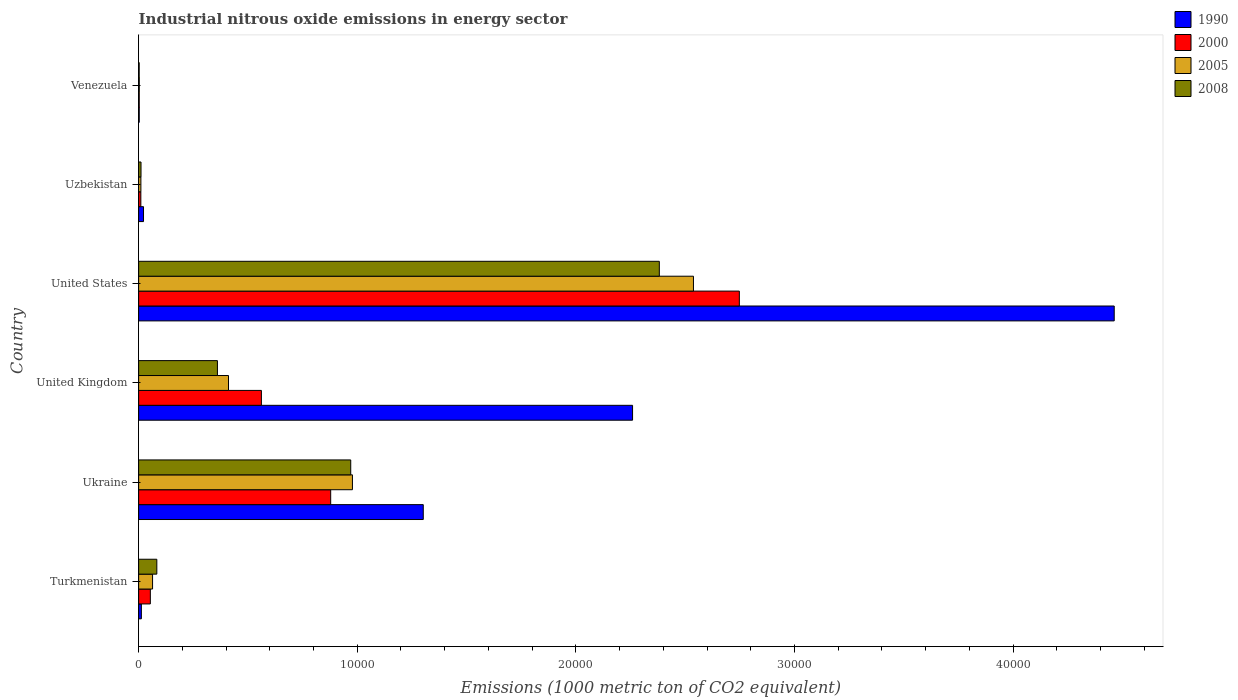How many different coloured bars are there?
Provide a short and direct response. 4. Are the number of bars per tick equal to the number of legend labels?
Keep it short and to the point. Yes. How many bars are there on the 6th tick from the top?
Make the answer very short. 4. How many bars are there on the 1st tick from the bottom?
Give a very brief answer. 4. What is the amount of industrial nitrous oxide emitted in 1990 in United States?
Make the answer very short. 4.46e+04. Across all countries, what is the maximum amount of industrial nitrous oxide emitted in 2008?
Make the answer very short. 2.38e+04. Across all countries, what is the minimum amount of industrial nitrous oxide emitted in 2000?
Your answer should be very brief. 27.9. In which country was the amount of industrial nitrous oxide emitted in 1990 minimum?
Offer a very short reply. Venezuela. What is the total amount of industrial nitrous oxide emitted in 2008 in the graph?
Offer a very short reply. 3.81e+04. What is the difference between the amount of industrial nitrous oxide emitted in 2005 in Ukraine and that in Uzbekistan?
Give a very brief answer. 9676.7. What is the difference between the amount of industrial nitrous oxide emitted in 2008 in Venezuela and the amount of industrial nitrous oxide emitted in 1990 in United Kingdom?
Ensure brevity in your answer.  -2.26e+04. What is the average amount of industrial nitrous oxide emitted in 2005 per country?
Give a very brief answer. 6673.38. What is the difference between the amount of industrial nitrous oxide emitted in 1990 and amount of industrial nitrous oxide emitted in 2000 in Ukraine?
Keep it short and to the point. 4235.2. What is the ratio of the amount of industrial nitrous oxide emitted in 2000 in United States to that in Uzbekistan?
Offer a very short reply. 270.45. Is the amount of industrial nitrous oxide emitted in 1990 in Ukraine less than that in United Kingdom?
Keep it short and to the point. Yes. Is the difference between the amount of industrial nitrous oxide emitted in 1990 in Uzbekistan and Venezuela greater than the difference between the amount of industrial nitrous oxide emitted in 2000 in Uzbekistan and Venezuela?
Offer a terse response. Yes. What is the difference between the highest and the second highest amount of industrial nitrous oxide emitted in 2005?
Give a very brief answer. 1.56e+04. What is the difference between the highest and the lowest amount of industrial nitrous oxide emitted in 1990?
Give a very brief answer. 4.46e+04. Is the sum of the amount of industrial nitrous oxide emitted in 2000 in Ukraine and Uzbekistan greater than the maximum amount of industrial nitrous oxide emitted in 1990 across all countries?
Your answer should be very brief. No. Is it the case that in every country, the sum of the amount of industrial nitrous oxide emitted in 2000 and amount of industrial nitrous oxide emitted in 2008 is greater than the sum of amount of industrial nitrous oxide emitted in 1990 and amount of industrial nitrous oxide emitted in 2005?
Offer a terse response. No. What does the 2nd bar from the bottom in United Kingdom represents?
Your response must be concise. 2000. Is it the case that in every country, the sum of the amount of industrial nitrous oxide emitted in 1990 and amount of industrial nitrous oxide emitted in 2008 is greater than the amount of industrial nitrous oxide emitted in 2005?
Offer a terse response. Yes. How many countries are there in the graph?
Offer a terse response. 6. Does the graph contain grids?
Make the answer very short. No. Where does the legend appear in the graph?
Make the answer very short. Top right. How many legend labels are there?
Keep it short and to the point. 4. How are the legend labels stacked?
Your response must be concise. Vertical. What is the title of the graph?
Keep it short and to the point. Industrial nitrous oxide emissions in energy sector. Does "1997" appear as one of the legend labels in the graph?
Keep it short and to the point. No. What is the label or title of the X-axis?
Keep it short and to the point. Emissions (1000 metric ton of CO2 equivalent). What is the Emissions (1000 metric ton of CO2 equivalent) of 1990 in Turkmenistan?
Provide a succinct answer. 125.6. What is the Emissions (1000 metric ton of CO2 equivalent) of 2000 in Turkmenistan?
Give a very brief answer. 535.7. What is the Emissions (1000 metric ton of CO2 equivalent) of 2005 in Turkmenistan?
Ensure brevity in your answer.  637.2. What is the Emissions (1000 metric ton of CO2 equivalent) of 2008 in Turkmenistan?
Give a very brief answer. 832.5. What is the Emissions (1000 metric ton of CO2 equivalent) of 1990 in Ukraine?
Offer a terse response. 1.30e+04. What is the Emissions (1000 metric ton of CO2 equivalent) of 2000 in Ukraine?
Offer a terse response. 8784.8. What is the Emissions (1000 metric ton of CO2 equivalent) of 2005 in Ukraine?
Provide a succinct answer. 9779.9. What is the Emissions (1000 metric ton of CO2 equivalent) in 2008 in Ukraine?
Make the answer very short. 9701.8. What is the Emissions (1000 metric ton of CO2 equivalent) in 1990 in United Kingdom?
Keep it short and to the point. 2.26e+04. What is the Emissions (1000 metric ton of CO2 equivalent) of 2000 in United Kingdom?
Keep it short and to the point. 5616. What is the Emissions (1000 metric ton of CO2 equivalent) in 2005 in United Kingdom?
Make the answer very short. 4111.2. What is the Emissions (1000 metric ton of CO2 equivalent) of 2008 in United Kingdom?
Offer a very short reply. 3604.6. What is the Emissions (1000 metric ton of CO2 equivalent) in 1990 in United States?
Your answer should be compact. 4.46e+04. What is the Emissions (1000 metric ton of CO2 equivalent) in 2000 in United States?
Provide a succinct answer. 2.75e+04. What is the Emissions (1000 metric ton of CO2 equivalent) of 2005 in United States?
Your answer should be compact. 2.54e+04. What is the Emissions (1000 metric ton of CO2 equivalent) of 2008 in United States?
Make the answer very short. 2.38e+04. What is the Emissions (1000 metric ton of CO2 equivalent) of 1990 in Uzbekistan?
Make the answer very short. 223.2. What is the Emissions (1000 metric ton of CO2 equivalent) of 2000 in Uzbekistan?
Give a very brief answer. 101.6. What is the Emissions (1000 metric ton of CO2 equivalent) in 2005 in Uzbekistan?
Keep it short and to the point. 103.2. What is the Emissions (1000 metric ton of CO2 equivalent) in 2008 in Uzbekistan?
Your response must be concise. 109.4. What is the Emissions (1000 metric ton of CO2 equivalent) of 1990 in Venezuela?
Ensure brevity in your answer.  27.9. What is the Emissions (1000 metric ton of CO2 equivalent) in 2000 in Venezuela?
Your answer should be compact. 27.9. What is the Emissions (1000 metric ton of CO2 equivalent) in 2005 in Venezuela?
Offer a terse response. 30.1. What is the Emissions (1000 metric ton of CO2 equivalent) in 2008 in Venezuela?
Offer a terse response. 25.4. Across all countries, what is the maximum Emissions (1000 metric ton of CO2 equivalent) in 1990?
Ensure brevity in your answer.  4.46e+04. Across all countries, what is the maximum Emissions (1000 metric ton of CO2 equivalent) in 2000?
Offer a very short reply. 2.75e+04. Across all countries, what is the maximum Emissions (1000 metric ton of CO2 equivalent) in 2005?
Your answer should be compact. 2.54e+04. Across all countries, what is the maximum Emissions (1000 metric ton of CO2 equivalent) in 2008?
Your answer should be compact. 2.38e+04. Across all countries, what is the minimum Emissions (1000 metric ton of CO2 equivalent) in 1990?
Your response must be concise. 27.9. Across all countries, what is the minimum Emissions (1000 metric ton of CO2 equivalent) of 2000?
Provide a succinct answer. 27.9. Across all countries, what is the minimum Emissions (1000 metric ton of CO2 equivalent) in 2005?
Keep it short and to the point. 30.1. Across all countries, what is the minimum Emissions (1000 metric ton of CO2 equivalent) in 2008?
Offer a very short reply. 25.4. What is the total Emissions (1000 metric ton of CO2 equivalent) of 1990 in the graph?
Offer a very short reply. 8.06e+04. What is the total Emissions (1000 metric ton of CO2 equivalent) of 2000 in the graph?
Your answer should be very brief. 4.25e+04. What is the total Emissions (1000 metric ton of CO2 equivalent) in 2005 in the graph?
Keep it short and to the point. 4.00e+04. What is the total Emissions (1000 metric ton of CO2 equivalent) of 2008 in the graph?
Make the answer very short. 3.81e+04. What is the difference between the Emissions (1000 metric ton of CO2 equivalent) of 1990 in Turkmenistan and that in Ukraine?
Keep it short and to the point. -1.29e+04. What is the difference between the Emissions (1000 metric ton of CO2 equivalent) in 2000 in Turkmenistan and that in Ukraine?
Provide a succinct answer. -8249.1. What is the difference between the Emissions (1000 metric ton of CO2 equivalent) in 2005 in Turkmenistan and that in Ukraine?
Give a very brief answer. -9142.7. What is the difference between the Emissions (1000 metric ton of CO2 equivalent) of 2008 in Turkmenistan and that in Ukraine?
Keep it short and to the point. -8869.3. What is the difference between the Emissions (1000 metric ton of CO2 equivalent) in 1990 in Turkmenistan and that in United Kingdom?
Keep it short and to the point. -2.25e+04. What is the difference between the Emissions (1000 metric ton of CO2 equivalent) in 2000 in Turkmenistan and that in United Kingdom?
Your response must be concise. -5080.3. What is the difference between the Emissions (1000 metric ton of CO2 equivalent) in 2005 in Turkmenistan and that in United Kingdom?
Your response must be concise. -3474. What is the difference between the Emissions (1000 metric ton of CO2 equivalent) of 2008 in Turkmenistan and that in United Kingdom?
Keep it short and to the point. -2772.1. What is the difference between the Emissions (1000 metric ton of CO2 equivalent) of 1990 in Turkmenistan and that in United States?
Keep it short and to the point. -4.45e+04. What is the difference between the Emissions (1000 metric ton of CO2 equivalent) of 2000 in Turkmenistan and that in United States?
Keep it short and to the point. -2.69e+04. What is the difference between the Emissions (1000 metric ton of CO2 equivalent) in 2005 in Turkmenistan and that in United States?
Your answer should be compact. -2.47e+04. What is the difference between the Emissions (1000 metric ton of CO2 equivalent) of 2008 in Turkmenistan and that in United States?
Offer a very short reply. -2.30e+04. What is the difference between the Emissions (1000 metric ton of CO2 equivalent) in 1990 in Turkmenistan and that in Uzbekistan?
Make the answer very short. -97.6. What is the difference between the Emissions (1000 metric ton of CO2 equivalent) in 2000 in Turkmenistan and that in Uzbekistan?
Provide a succinct answer. 434.1. What is the difference between the Emissions (1000 metric ton of CO2 equivalent) in 2005 in Turkmenistan and that in Uzbekistan?
Ensure brevity in your answer.  534. What is the difference between the Emissions (1000 metric ton of CO2 equivalent) of 2008 in Turkmenistan and that in Uzbekistan?
Provide a succinct answer. 723.1. What is the difference between the Emissions (1000 metric ton of CO2 equivalent) in 1990 in Turkmenistan and that in Venezuela?
Give a very brief answer. 97.7. What is the difference between the Emissions (1000 metric ton of CO2 equivalent) in 2000 in Turkmenistan and that in Venezuela?
Provide a short and direct response. 507.8. What is the difference between the Emissions (1000 metric ton of CO2 equivalent) in 2005 in Turkmenistan and that in Venezuela?
Provide a succinct answer. 607.1. What is the difference between the Emissions (1000 metric ton of CO2 equivalent) of 2008 in Turkmenistan and that in Venezuela?
Ensure brevity in your answer.  807.1. What is the difference between the Emissions (1000 metric ton of CO2 equivalent) in 1990 in Ukraine and that in United Kingdom?
Make the answer very short. -9573. What is the difference between the Emissions (1000 metric ton of CO2 equivalent) of 2000 in Ukraine and that in United Kingdom?
Make the answer very short. 3168.8. What is the difference between the Emissions (1000 metric ton of CO2 equivalent) in 2005 in Ukraine and that in United Kingdom?
Provide a short and direct response. 5668.7. What is the difference between the Emissions (1000 metric ton of CO2 equivalent) of 2008 in Ukraine and that in United Kingdom?
Provide a short and direct response. 6097.2. What is the difference between the Emissions (1000 metric ton of CO2 equivalent) of 1990 in Ukraine and that in United States?
Give a very brief answer. -3.16e+04. What is the difference between the Emissions (1000 metric ton of CO2 equivalent) of 2000 in Ukraine and that in United States?
Offer a very short reply. -1.87e+04. What is the difference between the Emissions (1000 metric ton of CO2 equivalent) of 2005 in Ukraine and that in United States?
Offer a very short reply. -1.56e+04. What is the difference between the Emissions (1000 metric ton of CO2 equivalent) in 2008 in Ukraine and that in United States?
Ensure brevity in your answer.  -1.41e+04. What is the difference between the Emissions (1000 metric ton of CO2 equivalent) in 1990 in Ukraine and that in Uzbekistan?
Offer a terse response. 1.28e+04. What is the difference between the Emissions (1000 metric ton of CO2 equivalent) in 2000 in Ukraine and that in Uzbekistan?
Make the answer very short. 8683.2. What is the difference between the Emissions (1000 metric ton of CO2 equivalent) of 2005 in Ukraine and that in Uzbekistan?
Keep it short and to the point. 9676.7. What is the difference between the Emissions (1000 metric ton of CO2 equivalent) in 2008 in Ukraine and that in Uzbekistan?
Offer a terse response. 9592.4. What is the difference between the Emissions (1000 metric ton of CO2 equivalent) in 1990 in Ukraine and that in Venezuela?
Provide a short and direct response. 1.30e+04. What is the difference between the Emissions (1000 metric ton of CO2 equivalent) of 2000 in Ukraine and that in Venezuela?
Make the answer very short. 8756.9. What is the difference between the Emissions (1000 metric ton of CO2 equivalent) in 2005 in Ukraine and that in Venezuela?
Keep it short and to the point. 9749.8. What is the difference between the Emissions (1000 metric ton of CO2 equivalent) in 2008 in Ukraine and that in Venezuela?
Your response must be concise. 9676.4. What is the difference between the Emissions (1000 metric ton of CO2 equivalent) of 1990 in United Kingdom and that in United States?
Your answer should be compact. -2.20e+04. What is the difference between the Emissions (1000 metric ton of CO2 equivalent) in 2000 in United Kingdom and that in United States?
Keep it short and to the point. -2.19e+04. What is the difference between the Emissions (1000 metric ton of CO2 equivalent) in 2005 in United Kingdom and that in United States?
Your answer should be very brief. -2.13e+04. What is the difference between the Emissions (1000 metric ton of CO2 equivalent) in 2008 in United Kingdom and that in United States?
Provide a short and direct response. -2.02e+04. What is the difference between the Emissions (1000 metric ton of CO2 equivalent) in 1990 in United Kingdom and that in Uzbekistan?
Give a very brief answer. 2.24e+04. What is the difference between the Emissions (1000 metric ton of CO2 equivalent) in 2000 in United Kingdom and that in Uzbekistan?
Offer a terse response. 5514.4. What is the difference between the Emissions (1000 metric ton of CO2 equivalent) in 2005 in United Kingdom and that in Uzbekistan?
Ensure brevity in your answer.  4008. What is the difference between the Emissions (1000 metric ton of CO2 equivalent) of 2008 in United Kingdom and that in Uzbekistan?
Ensure brevity in your answer.  3495.2. What is the difference between the Emissions (1000 metric ton of CO2 equivalent) of 1990 in United Kingdom and that in Venezuela?
Your response must be concise. 2.26e+04. What is the difference between the Emissions (1000 metric ton of CO2 equivalent) in 2000 in United Kingdom and that in Venezuela?
Ensure brevity in your answer.  5588.1. What is the difference between the Emissions (1000 metric ton of CO2 equivalent) of 2005 in United Kingdom and that in Venezuela?
Offer a very short reply. 4081.1. What is the difference between the Emissions (1000 metric ton of CO2 equivalent) of 2008 in United Kingdom and that in Venezuela?
Give a very brief answer. 3579.2. What is the difference between the Emissions (1000 metric ton of CO2 equivalent) of 1990 in United States and that in Uzbekistan?
Provide a short and direct response. 4.44e+04. What is the difference between the Emissions (1000 metric ton of CO2 equivalent) of 2000 in United States and that in Uzbekistan?
Offer a very short reply. 2.74e+04. What is the difference between the Emissions (1000 metric ton of CO2 equivalent) of 2005 in United States and that in Uzbekistan?
Your response must be concise. 2.53e+04. What is the difference between the Emissions (1000 metric ton of CO2 equivalent) of 2008 in United States and that in Uzbekistan?
Your answer should be very brief. 2.37e+04. What is the difference between the Emissions (1000 metric ton of CO2 equivalent) of 1990 in United States and that in Venezuela?
Your answer should be very brief. 4.46e+04. What is the difference between the Emissions (1000 metric ton of CO2 equivalent) in 2000 in United States and that in Venezuela?
Ensure brevity in your answer.  2.74e+04. What is the difference between the Emissions (1000 metric ton of CO2 equivalent) in 2005 in United States and that in Venezuela?
Provide a succinct answer. 2.53e+04. What is the difference between the Emissions (1000 metric ton of CO2 equivalent) of 2008 in United States and that in Venezuela?
Provide a short and direct response. 2.38e+04. What is the difference between the Emissions (1000 metric ton of CO2 equivalent) in 1990 in Uzbekistan and that in Venezuela?
Your answer should be compact. 195.3. What is the difference between the Emissions (1000 metric ton of CO2 equivalent) of 2000 in Uzbekistan and that in Venezuela?
Keep it short and to the point. 73.7. What is the difference between the Emissions (1000 metric ton of CO2 equivalent) in 2005 in Uzbekistan and that in Venezuela?
Keep it short and to the point. 73.1. What is the difference between the Emissions (1000 metric ton of CO2 equivalent) of 2008 in Uzbekistan and that in Venezuela?
Your response must be concise. 84. What is the difference between the Emissions (1000 metric ton of CO2 equivalent) of 1990 in Turkmenistan and the Emissions (1000 metric ton of CO2 equivalent) of 2000 in Ukraine?
Your answer should be compact. -8659.2. What is the difference between the Emissions (1000 metric ton of CO2 equivalent) of 1990 in Turkmenistan and the Emissions (1000 metric ton of CO2 equivalent) of 2005 in Ukraine?
Offer a very short reply. -9654.3. What is the difference between the Emissions (1000 metric ton of CO2 equivalent) of 1990 in Turkmenistan and the Emissions (1000 metric ton of CO2 equivalent) of 2008 in Ukraine?
Your answer should be very brief. -9576.2. What is the difference between the Emissions (1000 metric ton of CO2 equivalent) in 2000 in Turkmenistan and the Emissions (1000 metric ton of CO2 equivalent) in 2005 in Ukraine?
Your answer should be very brief. -9244.2. What is the difference between the Emissions (1000 metric ton of CO2 equivalent) in 2000 in Turkmenistan and the Emissions (1000 metric ton of CO2 equivalent) in 2008 in Ukraine?
Provide a succinct answer. -9166.1. What is the difference between the Emissions (1000 metric ton of CO2 equivalent) in 2005 in Turkmenistan and the Emissions (1000 metric ton of CO2 equivalent) in 2008 in Ukraine?
Your response must be concise. -9064.6. What is the difference between the Emissions (1000 metric ton of CO2 equivalent) in 1990 in Turkmenistan and the Emissions (1000 metric ton of CO2 equivalent) in 2000 in United Kingdom?
Your answer should be very brief. -5490.4. What is the difference between the Emissions (1000 metric ton of CO2 equivalent) in 1990 in Turkmenistan and the Emissions (1000 metric ton of CO2 equivalent) in 2005 in United Kingdom?
Ensure brevity in your answer.  -3985.6. What is the difference between the Emissions (1000 metric ton of CO2 equivalent) in 1990 in Turkmenistan and the Emissions (1000 metric ton of CO2 equivalent) in 2008 in United Kingdom?
Provide a short and direct response. -3479. What is the difference between the Emissions (1000 metric ton of CO2 equivalent) in 2000 in Turkmenistan and the Emissions (1000 metric ton of CO2 equivalent) in 2005 in United Kingdom?
Your answer should be compact. -3575.5. What is the difference between the Emissions (1000 metric ton of CO2 equivalent) in 2000 in Turkmenistan and the Emissions (1000 metric ton of CO2 equivalent) in 2008 in United Kingdom?
Provide a succinct answer. -3068.9. What is the difference between the Emissions (1000 metric ton of CO2 equivalent) of 2005 in Turkmenistan and the Emissions (1000 metric ton of CO2 equivalent) of 2008 in United Kingdom?
Ensure brevity in your answer.  -2967.4. What is the difference between the Emissions (1000 metric ton of CO2 equivalent) in 1990 in Turkmenistan and the Emissions (1000 metric ton of CO2 equivalent) in 2000 in United States?
Make the answer very short. -2.74e+04. What is the difference between the Emissions (1000 metric ton of CO2 equivalent) in 1990 in Turkmenistan and the Emissions (1000 metric ton of CO2 equivalent) in 2005 in United States?
Your response must be concise. -2.53e+04. What is the difference between the Emissions (1000 metric ton of CO2 equivalent) in 1990 in Turkmenistan and the Emissions (1000 metric ton of CO2 equivalent) in 2008 in United States?
Offer a very short reply. -2.37e+04. What is the difference between the Emissions (1000 metric ton of CO2 equivalent) in 2000 in Turkmenistan and the Emissions (1000 metric ton of CO2 equivalent) in 2005 in United States?
Offer a terse response. -2.48e+04. What is the difference between the Emissions (1000 metric ton of CO2 equivalent) in 2000 in Turkmenistan and the Emissions (1000 metric ton of CO2 equivalent) in 2008 in United States?
Your answer should be very brief. -2.33e+04. What is the difference between the Emissions (1000 metric ton of CO2 equivalent) in 2005 in Turkmenistan and the Emissions (1000 metric ton of CO2 equivalent) in 2008 in United States?
Make the answer very short. -2.32e+04. What is the difference between the Emissions (1000 metric ton of CO2 equivalent) in 1990 in Turkmenistan and the Emissions (1000 metric ton of CO2 equivalent) in 2005 in Uzbekistan?
Your answer should be very brief. 22.4. What is the difference between the Emissions (1000 metric ton of CO2 equivalent) in 1990 in Turkmenistan and the Emissions (1000 metric ton of CO2 equivalent) in 2008 in Uzbekistan?
Offer a very short reply. 16.2. What is the difference between the Emissions (1000 metric ton of CO2 equivalent) in 2000 in Turkmenistan and the Emissions (1000 metric ton of CO2 equivalent) in 2005 in Uzbekistan?
Your response must be concise. 432.5. What is the difference between the Emissions (1000 metric ton of CO2 equivalent) of 2000 in Turkmenistan and the Emissions (1000 metric ton of CO2 equivalent) of 2008 in Uzbekistan?
Keep it short and to the point. 426.3. What is the difference between the Emissions (1000 metric ton of CO2 equivalent) in 2005 in Turkmenistan and the Emissions (1000 metric ton of CO2 equivalent) in 2008 in Uzbekistan?
Your response must be concise. 527.8. What is the difference between the Emissions (1000 metric ton of CO2 equivalent) of 1990 in Turkmenistan and the Emissions (1000 metric ton of CO2 equivalent) of 2000 in Venezuela?
Your answer should be very brief. 97.7. What is the difference between the Emissions (1000 metric ton of CO2 equivalent) of 1990 in Turkmenistan and the Emissions (1000 metric ton of CO2 equivalent) of 2005 in Venezuela?
Your answer should be very brief. 95.5. What is the difference between the Emissions (1000 metric ton of CO2 equivalent) in 1990 in Turkmenistan and the Emissions (1000 metric ton of CO2 equivalent) in 2008 in Venezuela?
Your response must be concise. 100.2. What is the difference between the Emissions (1000 metric ton of CO2 equivalent) in 2000 in Turkmenistan and the Emissions (1000 metric ton of CO2 equivalent) in 2005 in Venezuela?
Your answer should be very brief. 505.6. What is the difference between the Emissions (1000 metric ton of CO2 equivalent) in 2000 in Turkmenistan and the Emissions (1000 metric ton of CO2 equivalent) in 2008 in Venezuela?
Give a very brief answer. 510.3. What is the difference between the Emissions (1000 metric ton of CO2 equivalent) of 2005 in Turkmenistan and the Emissions (1000 metric ton of CO2 equivalent) of 2008 in Venezuela?
Offer a terse response. 611.8. What is the difference between the Emissions (1000 metric ton of CO2 equivalent) of 1990 in Ukraine and the Emissions (1000 metric ton of CO2 equivalent) of 2000 in United Kingdom?
Give a very brief answer. 7404. What is the difference between the Emissions (1000 metric ton of CO2 equivalent) of 1990 in Ukraine and the Emissions (1000 metric ton of CO2 equivalent) of 2005 in United Kingdom?
Provide a short and direct response. 8908.8. What is the difference between the Emissions (1000 metric ton of CO2 equivalent) in 1990 in Ukraine and the Emissions (1000 metric ton of CO2 equivalent) in 2008 in United Kingdom?
Offer a terse response. 9415.4. What is the difference between the Emissions (1000 metric ton of CO2 equivalent) of 2000 in Ukraine and the Emissions (1000 metric ton of CO2 equivalent) of 2005 in United Kingdom?
Provide a succinct answer. 4673.6. What is the difference between the Emissions (1000 metric ton of CO2 equivalent) of 2000 in Ukraine and the Emissions (1000 metric ton of CO2 equivalent) of 2008 in United Kingdom?
Provide a short and direct response. 5180.2. What is the difference between the Emissions (1000 metric ton of CO2 equivalent) in 2005 in Ukraine and the Emissions (1000 metric ton of CO2 equivalent) in 2008 in United Kingdom?
Your answer should be compact. 6175.3. What is the difference between the Emissions (1000 metric ton of CO2 equivalent) in 1990 in Ukraine and the Emissions (1000 metric ton of CO2 equivalent) in 2000 in United States?
Your answer should be very brief. -1.45e+04. What is the difference between the Emissions (1000 metric ton of CO2 equivalent) in 1990 in Ukraine and the Emissions (1000 metric ton of CO2 equivalent) in 2005 in United States?
Ensure brevity in your answer.  -1.24e+04. What is the difference between the Emissions (1000 metric ton of CO2 equivalent) in 1990 in Ukraine and the Emissions (1000 metric ton of CO2 equivalent) in 2008 in United States?
Provide a short and direct response. -1.08e+04. What is the difference between the Emissions (1000 metric ton of CO2 equivalent) of 2000 in Ukraine and the Emissions (1000 metric ton of CO2 equivalent) of 2005 in United States?
Your answer should be compact. -1.66e+04. What is the difference between the Emissions (1000 metric ton of CO2 equivalent) of 2000 in Ukraine and the Emissions (1000 metric ton of CO2 equivalent) of 2008 in United States?
Your response must be concise. -1.50e+04. What is the difference between the Emissions (1000 metric ton of CO2 equivalent) of 2005 in Ukraine and the Emissions (1000 metric ton of CO2 equivalent) of 2008 in United States?
Offer a terse response. -1.40e+04. What is the difference between the Emissions (1000 metric ton of CO2 equivalent) of 1990 in Ukraine and the Emissions (1000 metric ton of CO2 equivalent) of 2000 in Uzbekistan?
Provide a short and direct response. 1.29e+04. What is the difference between the Emissions (1000 metric ton of CO2 equivalent) of 1990 in Ukraine and the Emissions (1000 metric ton of CO2 equivalent) of 2005 in Uzbekistan?
Provide a short and direct response. 1.29e+04. What is the difference between the Emissions (1000 metric ton of CO2 equivalent) of 1990 in Ukraine and the Emissions (1000 metric ton of CO2 equivalent) of 2008 in Uzbekistan?
Keep it short and to the point. 1.29e+04. What is the difference between the Emissions (1000 metric ton of CO2 equivalent) of 2000 in Ukraine and the Emissions (1000 metric ton of CO2 equivalent) of 2005 in Uzbekistan?
Offer a terse response. 8681.6. What is the difference between the Emissions (1000 metric ton of CO2 equivalent) of 2000 in Ukraine and the Emissions (1000 metric ton of CO2 equivalent) of 2008 in Uzbekistan?
Give a very brief answer. 8675.4. What is the difference between the Emissions (1000 metric ton of CO2 equivalent) in 2005 in Ukraine and the Emissions (1000 metric ton of CO2 equivalent) in 2008 in Uzbekistan?
Your response must be concise. 9670.5. What is the difference between the Emissions (1000 metric ton of CO2 equivalent) of 1990 in Ukraine and the Emissions (1000 metric ton of CO2 equivalent) of 2000 in Venezuela?
Ensure brevity in your answer.  1.30e+04. What is the difference between the Emissions (1000 metric ton of CO2 equivalent) in 1990 in Ukraine and the Emissions (1000 metric ton of CO2 equivalent) in 2005 in Venezuela?
Your response must be concise. 1.30e+04. What is the difference between the Emissions (1000 metric ton of CO2 equivalent) in 1990 in Ukraine and the Emissions (1000 metric ton of CO2 equivalent) in 2008 in Venezuela?
Provide a succinct answer. 1.30e+04. What is the difference between the Emissions (1000 metric ton of CO2 equivalent) of 2000 in Ukraine and the Emissions (1000 metric ton of CO2 equivalent) of 2005 in Venezuela?
Offer a terse response. 8754.7. What is the difference between the Emissions (1000 metric ton of CO2 equivalent) of 2000 in Ukraine and the Emissions (1000 metric ton of CO2 equivalent) of 2008 in Venezuela?
Provide a short and direct response. 8759.4. What is the difference between the Emissions (1000 metric ton of CO2 equivalent) in 2005 in Ukraine and the Emissions (1000 metric ton of CO2 equivalent) in 2008 in Venezuela?
Make the answer very short. 9754.5. What is the difference between the Emissions (1000 metric ton of CO2 equivalent) in 1990 in United Kingdom and the Emissions (1000 metric ton of CO2 equivalent) in 2000 in United States?
Offer a very short reply. -4884.9. What is the difference between the Emissions (1000 metric ton of CO2 equivalent) of 1990 in United Kingdom and the Emissions (1000 metric ton of CO2 equivalent) of 2005 in United States?
Make the answer very short. -2785.7. What is the difference between the Emissions (1000 metric ton of CO2 equivalent) in 1990 in United Kingdom and the Emissions (1000 metric ton of CO2 equivalent) in 2008 in United States?
Provide a succinct answer. -1224.8. What is the difference between the Emissions (1000 metric ton of CO2 equivalent) in 2000 in United Kingdom and the Emissions (1000 metric ton of CO2 equivalent) in 2005 in United States?
Provide a succinct answer. -1.98e+04. What is the difference between the Emissions (1000 metric ton of CO2 equivalent) in 2000 in United Kingdom and the Emissions (1000 metric ton of CO2 equivalent) in 2008 in United States?
Offer a very short reply. -1.82e+04. What is the difference between the Emissions (1000 metric ton of CO2 equivalent) of 2005 in United Kingdom and the Emissions (1000 metric ton of CO2 equivalent) of 2008 in United States?
Your answer should be compact. -1.97e+04. What is the difference between the Emissions (1000 metric ton of CO2 equivalent) in 1990 in United Kingdom and the Emissions (1000 metric ton of CO2 equivalent) in 2000 in Uzbekistan?
Offer a very short reply. 2.25e+04. What is the difference between the Emissions (1000 metric ton of CO2 equivalent) of 1990 in United Kingdom and the Emissions (1000 metric ton of CO2 equivalent) of 2005 in Uzbekistan?
Make the answer very short. 2.25e+04. What is the difference between the Emissions (1000 metric ton of CO2 equivalent) of 1990 in United Kingdom and the Emissions (1000 metric ton of CO2 equivalent) of 2008 in Uzbekistan?
Your response must be concise. 2.25e+04. What is the difference between the Emissions (1000 metric ton of CO2 equivalent) of 2000 in United Kingdom and the Emissions (1000 metric ton of CO2 equivalent) of 2005 in Uzbekistan?
Ensure brevity in your answer.  5512.8. What is the difference between the Emissions (1000 metric ton of CO2 equivalent) in 2000 in United Kingdom and the Emissions (1000 metric ton of CO2 equivalent) in 2008 in Uzbekistan?
Provide a short and direct response. 5506.6. What is the difference between the Emissions (1000 metric ton of CO2 equivalent) in 2005 in United Kingdom and the Emissions (1000 metric ton of CO2 equivalent) in 2008 in Uzbekistan?
Keep it short and to the point. 4001.8. What is the difference between the Emissions (1000 metric ton of CO2 equivalent) in 1990 in United Kingdom and the Emissions (1000 metric ton of CO2 equivalent) in 2000 in Venezuela?
Offer a very short reply. 2.26e+04. What is the difference between the Emissions (1000 metric ton of CO2 equivalent) of 1990 in United Kingdom and the Emissions (1000 metric ton of CO2 equivalent) of 2005 in Venezuela?
Provide a short and direct response. 2.26e+04. What is the difference between the Emissions (1000 metric ton of CO2 equivalent) of 1990 in United Kingdom and the Emissions (1000 metric ton of CO2 equivalent) of 2008 in Venezuela?
Ensure brevity in your answer.  2.26e+04. What is the difference between the Emissions (1000 metric ton of CO2 equivalent) in 2000 in United Kingdom and the Emissions (1000 metric ton of CO2 equivalent) in 2005 in Venezuela?
Give a very brief answer. 5585.9. What is the difference between the Emissions (1000 metric ton of CO2 equivalent) of 2000 in United Kingdom and the Emissions (1000 metric ton of CO2 equivalent) of 2008 in Venezuela?
Your answer should be compact. 5590.6. What is the difference between the Emissions (1000 metric ton of CO2 equivalent) in 2005 in United Kingdom and the Emissions (1000 metric ton of CO2 equivalent) in 2008 in Venezuela?
Make the answer very short. 4085.8. What is the difference between the Emissions (1000 metric ton of CO2 equivalent) of 1990 in United States and the Emissions (1000 metric ton of CO2 equivalent) of 2000 in Uzbekistan?
Provide a short and direct response. 4.45e+04. What is the difference between the Emissions (1000 metric ton of CO2 equivalent) in 1990 in United States and the Emissions (1000 metric ton of CO2 equivalent) in 2005 in Uzbekistan?
Your answer should be very brief. 4.45e+04. What is the difference between the Emissions (1000 metric ton of CO2 equivalent) in 1990 in United States and the Emissions (1000 metric ton of CO2 equivalent) in 2008 in Uzbekistan?
Ensure brevity in your answer.  4.45e+04. What is the difference between the Emissions (1000 metric ton of CO2 equivalent) of 2000 in United States and the Emissions (1000 metric ton of CO2 equivalent) of 2005 in Uzbekistan?
Your response must be concise. 2.74e+04. What is the difference between the Emissions (1000 metric ton of CO2 equivalent) of 2000 in United States and the Emissions (1000 metric ton of CO2 equivalent) of 2008 in Uzbekistan?
Your response must be concise. 2.74e+04. What is the difference between the Emissions (1000 metric ton of CO2 equivalent) in 2005 in United States and the Emissions (1000 metric ton of CO2 equivalent) in 2008 in Uzbekistan?
Make the answer very short. 2.53e+04. What is the difference between the Emissions (1000 metric ton of CO2 equivalent) in 1990 in United States and the Emissions (1000 metric ton of CO2 equivalent) in 2000 in Venezuela?
Give a very brief answer. 4.46e+04. What is the difference between the Emissions (1000 metric ton of CO2 equivalent) of 1990 in United States and the Emissions (1000 metric ton of CO2 equivalent) of 2005 in Venezuela?
Your answer should be very brief. 4.46e+04. What is the difference between the Emissions (1000 metric ton of CO2 equivalent) in 1990 in United States and the Emissions (1000 metric ton of CO2 equivalent) in 2008 in Venezuela?
Provide a short and direct response. 4.46e+04. What is the difference between the Emissions (1000 metric ton of CO2 equivalent) of 2000 in United States and the Emissions (1000 metric ton of CO2 equivalent) of 2005 in Venezuela?
Your response must be concise. 2.74e+04. What is the difference between the Emissions (1000 metric ton of CO2 equivalent) in 2000 in United States and the Emissions (1000 metric ton of CO2 equivalent) in 2008 in Venezuela?
Ensure brevity in your answer.  2.75e+04. What is the difference between the Emissions (1000 metric ton of CO2 equivalent) of 2005 in United States and the Emissions (1000 metric ton of CO2 equivalent) of 2008 in Venezuela?
Ensure brevity in your answer.  2.54e+04. What is the difference between the Emissions (1000 metric ton of CO2 equivalent) in 1990 in Uzbekistan and the Emissions (1000 metric ton of CO2 equivalent) in 2000 in Venezuela?
Your answer should be compact. 195.3. What is the difference between the Emissions (1000 metric ton of CO2 equivalent) in 1990 in Uzbekistan and the Emissions (1000 metric ton of CO2 equivalent) in 2005 in Venezuela?
Your response must be concise. 193.1. What is the difference between the Emissions (1000 metric ton of CO2 equivalent) in 1990 in Uzbekistan and the Emissions (1000 metric ton of CO2 equivalent) in 2008 in Venezuela?
Ensure brevity in your answer.  197.8. What is the difference between the Emissions (1000 metric ton of CO2 equivalent) in 2000 in Uzbekistan and the Emissions (1000 metric ton of CO2 equivalent) in 2005 in Venezuela?
Your answer should be compact. 71.5. What is the difference between the Emissions (1000 metric ton of CO2 equivalent) of 2000 in Uzbekistan and the Emissions (1000 metric ton of CO2 equivalent) of 2008 in Venezuela?
Ensure brevity in your answer.  76.2. What is the difference between the Emissions (1000 metric ton of CO2 equivalent) in 2005 in Uzbekistan and the Emissions (1000 metric ton of CO2 equivalent) in 2008 in Venezuela?
Provide a succinct answer. 77.8. What is the average Emissions (1000 metric ton of CO2 equivalent) in 1990 per country?
Your response must be concise. 1.34e+04. What is the average Emissions (1000 metric ton of CO2 equivalent) in 2000 per country?
Make the answer very short. 7090.65. What is the average Emissions (1000 metric ton of CO2 equivalent) in 2005 per country?
Provide a short and direct response. 6673.38. What is the average Emissions (1000 metric ton of CO2 equivalent) in 2008 per country?
Your answer should be very brief. 6348.58. What is the difference between the Emissions (1000 metric ton of CO2 equivalent) of 1990 and Emissions (1000 metric ton of CO2 equivalent) of 2000 in Turkmenistan?
Your response must be concise. -410.1. What is the difference between the Emissions (1000 metric ton of CO2 equivalent) of 1990 and Emissions (1000 metric ton of CO2 equivalent) of 2005 in Turkmenistan?
Offer a very short reply. -511.6. What is the difference between the Emissions (1000 metric ton of CO2 equivalent) of 1990 and Emissions (1000 metric ton of CO2 equivalent) of 2008 in Turkmenistan?
Ensure brevity in your answer.  -706.9. What is the difference between the Emissions (1000 metric ton of CO2 equivalent) of 2000 and Emissions (1000 metric ton of CO2 equivalent) of 2005 in Turkmenistan?
Your response must be concise. -101.5. What is the difference between the Emissions (1000 metric ton of CO2 equivalent) in 2000 and Emissions (1000 metric ton of CO2 equivalent) in 2008 in Turkmenistan?
Your answer should be compact. -296.8. What is the difference between the Emissions (1000 metric ton of CO2 equivalent) in 2005 and Emissions (1000 metric ton of CO2 equivalent) in 2008 in Turkmenistan?
Your answer should be very brief. -195.3. What is the difference between the Emissions (1000 metric ton of CO2 equivalent) of 1990 and Emissions (1000 metric ton of CO2 equivalent) of 2000 in Ukraine?
Ensure brevity in your answer.  4235.2. What is the difference between the Emissions (1000 metric ton of CO2 equivalent) in 1990 and Emissions (1000 metric ton of CO2 equivalent) in 2005 in Ukraine?
Your response must be concise. 3240.1. What is the difference between the Emissions (1000 metric ton of CO2 equivalent) in 1990 and Emissions (1000 metric ton of CO2 equivalent) in 2008 in Ukraine?
Ensure brevity in your answer.  3318.2. What is the difference between the Emissions (1000 metric ton of CO2 equivalent) in 2000 and Emissions (1000 metric ton of CO2 equivalent) in 2005 in Ukraine?
Your answer should be very brief. -995.1. What is the difference between the Emissions (1000 metric ton of CO2 equivalent) in 2000 and Emissions (1000 metric ton of CO2 equivalent) in 2008 in Ukraine?
Your answer should be compact. -917. What is the difference between the Emissions (1000 metric ton of CO2 equivalent) of 2005 and Emissions (1000 metric ton of CO2 equivalent) of 2008 in Ukraine?
Offer a terse response. 78.1. What is the difference between the Emissions (1000 metric ton of CO2 equivalent) in 1990 and Emissions (1000 metric ton of CO2 equivalent) in 2000 in United Kingdom?
Your response must be concise. 1.70e+04. What is the difference between the Emissions (1000 metric ton of CO2 equivalent) in 1990 and Emissions (1000 metric ton of CO2 equivalent) in 2005 in United Kingdom?
Make the answer very short. 1.85e+04. What is the difference between the Emissions (1000 metric ton of CO2 equivalent) of 1990 and Emissions (1000 metric ton of CO2 equivalent) of 2008 in United Kingdom?
Your answer should be compact. 1.90e+04. What is the difference between the Emissions (1000 metric ton of CO2 equivalent) of 2000 and Emissions (1000 metric ton of CO2 equivalent) of 2005 in United Kingdom?
Give a very brief answer. 1504.8. What is the difference between the Emissions (1000 metric ton of CO2 equivalent) of 2000 and Emissions (1000 metric ton of CO2 equivalent) of 2008 in United Kingdom?
Your answer should be compact. 2011.4. What is the difference between the Emissions (1000 metric ton of CO2 equivalent) in 2005 and Emissions (1000 metric ton of CO2 equivalent) in 2008 in United Kingdom?
Your answer should be compact. 506.6. What is the difference between the Emissions (1000 metric ton of CO2 equivalent) of 1990 and Emissions (1000 metric ton of CO2 equivalent) of 2000 in United States?
Offer a very short reply. 1.71e+04. What is the difference between the Emissions (1000 metric ton of CO2 equivalent) of 1990 and Emissions (1000 metric ton of CO2 equivalent) of 2005 in United States?
Provide a succinct answer. 1.92e+04. What is the difference between the Emissions (1000 metric ton of CO2 equivalent) in 1990 and Emissions (1000 metric ton of CO2 equivalent) in 2008 in United States?
Give a very brief answer. 2.08e+04. What is the difference between the Emissions (1000 metric ton of CO2 equivalent) in 2000 and Emissions (1000 metric ton of CO2 equivalent) in 2005 in United States?
Offer a terse response. 2099.2. What is the difference between the Emissions (1000 metric ton of CO2 equivalent) of 2000 and Emissions (1000 metric ton of CO2 equivalent) of 2008 in United States?
Your response must be concise. 3660.1. What is the difference between the Emissions (1000 metric ton of CO2 equivalent) of 2005 and Emissions (1000 metric ton of CO2 equivalent) of 2008 in United States?
Ensure brevity in your answer.  1560.9. What is the difference between the Emissions (1000 metric ton of CO2 equivalent) in 1990 and Emissions (1000 metric ton of CO2 equivalent) in 2000 in Uzbekistan?
Offer a terse response. 121.6. What is the difference between the Emissions (1000 metric ton of CO2 equivalent) of 1990 and Emissions (1000 metric ton of CO2 equivalent) of 2005 in Uzbekistan?
Give a very brief answer. 120. What is the difference between the Emissions (1000 metric ton of CO2 equivalent) of 1990 and Emissions (1000 metric ton of CO2 equivalent) of 2008 in Uzbekistan?
Your answer should be compact. 113.8. What is the difference between the Emissions (1000 metric ton of CO2 equivalent) in 2000 and Emissions (1000 metric ton of CO2 equivalent) in 2005 in Uzbekistan?
Offer a very short reply. -1.6. What is the difference between the Emissions (1000 metric ton of CO2 equivalent) in 2000 and Emissions (1000 metric ton of CO2 equivalent) in 2008 in Uzbekistan?
Your answer should be compact. -7.8. What is the difference between the Emissions (1000 metric ton of CO2 equivalent) of 2005 and Emissions (1000 metric ton of CO2 equivalent) of 2008 in Uzbekistan?
Provide a short and direct response. -6.2. What is the difference between the Emissions (1000 metric ton of CO2 equivalent) of 2000 and Emissions (1000 metric ton of CO2 equivalent) of 2005 in Venezuela?
Your answer should be compact. -2.2. What is the difference between the Emissions (1000 metric ton of CO2 equivalent) of 2000 and Emissions (1000 metric ton of CO2 equivalent) of 2008 in Venezuela?
Give a very brief answer. 2.5. What is the ratio of the Emissions (1000 metric ton of CO2 equivalent) of 1990 in Turkmenistan to that in Ukraine?
Offer a terse response. 0.01. What is the ratio of the Emissions (1000 metric ton of CO2 equivalent) in 2000 in Turkmenistan to that in Ukraine?
Provide a short and direct response. 0.06. What is the ratio of the Emissions (1000 metric ton of CO2 equivalent) of 2005 in Turkmenistan to that in Ukraine?
Ensure brevity in your answer.  0.07. What is the ratio of the Emissions (1000 metric ton of CO2 equivalent) in 2008 in Turkmenistan to that in Ukraine?
Provide a succinct answer. 0.09. What is the ratio of the Emissions (1000 metric ton of CO2 equivalent) of 1990 in Turkmenistan to that in United Kingdom?
Offer a very short reply. 0.01. What is the ratio of the Emissions (1000 metric ton of CO2 equivalent) of 2000 in Turkmenistan to that in United Kingdom?
Provide a succinct answer. 0.1. What is the ratio of the Emissions (1000 metric ton of CO2 equivalent) in 2005 in Turkmenistan to that in United Kingdom?
Your answer should be very brief. 0.15. What is the ratio of the Emissions (1000 metric ton of CO2 equivalent) in 2008 in Turkmenistan to that in United Kingdom?
Ensure brevity in your answer.  0.23. What is the ratio of the Emissions (1000 metric ton of CO2 equivalent) in 1990 in Turkmenistan to that in United States?
Your response must be concise. 0. What is the ratio of the Emissions (1000 metric ton of CO2 equivalent) of 2000 in Turkmenistan to that in United States?
Your answer should be very brief. 0.02. What is the ratio of the Emissions (1000 metric ton of CO2 equivalent) in 2005 in Turkmenistan to that in United States?
Offer a very short reply. 0.03. What is the ratio of the Emissions (1000 metric ton of CO2 equivalent) in 2008 in Turkmenistan to that in United States?
Offer a very short reply. 0.04. What is the ratio of the Emissions (1000 metric ton of CO2 equivalent) in 1990 in Turkmenistan to that in Uzbekistan?
Offer a terse response. 0.56. What is the ratio of the Emissions (1000 metric ton of CO2 equivalent) in 2000 in Turkmenistan to that in Uzbekistan?
Give a very brief answer. 5.27. What is the ratio of the Emissions (1000 metric ton of CO2 equivalent) in 2005 in Turkmenistan to that in Uzbekistan?
Your answer should be compact. 6.17. What is the ratio of the Emissions (1000 metric ton of CO2 equivalent) in 2008 in Turkmenistan to that in Uzbekistan?
Provide a short and direct response. 7.61. What is the ratio of the Emissions (1000 metric ton of CO2 equivalent) in 1990 in Turkmenistan to that in Venezuela?
Give a very brief answer. 4.5. What is the ratio of the Emissions (1000 metric ton of CO2 equivalent) in 2000 in Turkmenistan to that in Venezuela?
Ensure brevity in your answer.  19.2. What is the ratio of the Emissions (1000 metric ton of CO2 equivalent) of 2005 in Turkmenistan to that in Venezuela?
Your answer should be compact. 21.17. What is the ratio of the Emissions (1000 metric ton of CO2 equivalent) in 2008 in Turkmenistan to that in Venezuela?
Your response must be concise. 32.78. What is the ratio of the Emissions (1000 metric ton of CO2 equivalent) of 1990 in Ukraine to that in United Kingdom?
Make the answer very short. 0.58. What is the ratio of the Emissions (1000 metric ton of CO2 equivalent) of 2000 in Ukraine to that in United Kingdom?
Make the answer very short. 1.56. What is the ratio of the Emissions (1000 metric ton of CO2 equivalent) of 2005 in Ukraine to that in United Kingdom?
Your answer should be very brief. 2.38. What is the ratio of the Emissions (1000 metric ton of CO2 equivalent) of 2008 in Ukraine to that in United Kingdom?
Your response must be concise. 2.69. What is the ratio of the Emissions (1000 metric ton of CO2 equivalent) in 1990 in Ukraine to that in United States?
Your answer should be compact. 0.29. What is the ratio of the Emissions (1000 metric ton of CO2 equivalent) of 2000 in Ukraine to that in United States?
Give a very brief answer. 0.32. What is the ratio of the Emissions (1000 metric ton of CO2 equivalent) of 2005 in Ukraine to that in United States?
Provide a succinct answer. 0.39. What is the ratio of the Emissions (1000 metric ton of CO2 equivalent) in 2008 in Ukraine to that in United States?
Offer a terse response. 0.41. What is the ratio of the Emissions (1000 metric ton of CO2 equivalent) in 1990 in Ukraine to that in Uzbekistan?
Provide a succinct answer. 58.33. What is the ratio of the Emissions (1000 metric ton of CO2 equivalent) of 2000 in Ukraine to that in Uzbekistan?
Your answer should be very brief. 86.46. What is the ratio of the Emissions (1000 metric ton of CO2 equivalent) in 2005 in Ukraine to that in Uzbekistan?
Offer a terse response. 94.77. What is the ratio of the Emissions (1000 metric ton of CO2 equivalent) of 2008 in Ukraine to that in Uzbekistan?
Provide a succinct answer. 88.68. What is the ratio of the Emissions (1000 metric ton of CO2 equivalent) in 1990 in Ukraine to that in Venezuela?
Give a very brief answer. 466.67. What is the ratio of the Emissions (1000 metric ton of CO2 equivalent) in 2000 in Ukraine to that in Venezuela?
Provide a short and direct response. 314.87. What is the ratio of the Emissions (1000 metric ton of CO2 equivalent) of 2005 in Ukraine to that in Venezuela?
Provide a short and direct response. 324.91. What is the ratio of the Emissions (1000 metric ton of CO2 equivalent) in 2008 in Ukraine to that in Venezuela?
Offer a very short reply. 381.96. What is the ratio of the Emissions (1000 metric ton of CO2 equivalent) of 1990 in United Kingdom to that in United States?
Offer a terse response. 0.51. What is the ratio of the Emissions (1000 metric ton of CO2 equivalent) of 2000 in United Kingdom to that in United States?
Your answer should be compact. 0.2. What is the ratio of the Emissions (1000 metric ton of CO2 equivalent) in 2005 in United Kingdom to that in United States?
Provide a succinct answer. 0.16. What is the ratio of the Emissions (1000 metric ton of CO2 equivalent) of 2008 in United Kingdom to that in United States?
Ensure brevity in your answer.  0.15. What is the ratio of the Emissions (1000 metric ton of CO2 equivalent) of 1990 in United Kingdom to that in Uzbekistan?
Offer a terse response. 101.22. What is the ratio of the Emissions (1000 metric ton of CO2 equivalent) in 2000 in United Kingdom to that in Uzbekistan?
Offer a terse response. 55.28. What is the ratio of the Emissions (1000 metric ton of CO2 equivalent) of 2005 in United Kingdom to that in Uzbekistan?
Make the answer very short. 39.84. What is the ratio of the Emissions (1000 metric ton of CO2 equivalent) in 2008 in United Kingdom to that in Uzbekistan?
Your answer should be compact. 32.95. What is the ratio of the Emissions (1000 metric ton of CO2 equivalent) of 1990 in United Kingdom to that in Venezuela?
Your response must be concise. 809.78. What is the ratio of the Emissions (1000 metric ton of CO2 equivalent) of 2000 in United Kingdom to that in Venezuela?
Keep it short and to the point. 201.29. What is the ratio of the Emissions (1000 metric ton of CO2 equivalent) of 2005 in United Kingdom to that in Venezuela?
Your answer should be very brief. 136.58. What is the ratio of the Emissions (1000 metric ton of CO2 equivalent) of 2008 in United Kingdom to that in Venezuela?
Provide a succinct answer. 141.91. What is the ratio of the Emissions (1000 metric ton of CO2 equivalent) of 1990 in United States to that in Uzbekistan?
Make the answer very short. 199.93. What is the ratio of the Emissions (1000 metric ton of CO2 equivalent) of 2000 in United States to that in Uzbekistan?
Your answer should be very brief. 270.45. What is the ratio of the Emissions (1000 metric ton of CO2 equivalent) in 2005 in United States to that in Uzbekistan?
Your response must be concise. 245.92. What is the ratio of the Emissions (1000 metric ton of CO2 equivalent) in 2008 in United States to that in Uzbekistan?
Provide a short and direct response. 217.71. What is the ratio of the Emissions (1000 metric ton of CO2 equivalent) of 1990 in United States to that in Venezuela?
Make the answer very short. 1599.46. What is the ratio of the Emissions (1000 metric ton of CO2 equivalent) in 2000 in United States to that in Venezuela?
Offer a very short reply. 984.87. What is the ratio of the Emissions (1000 metric ton of CO2 equivalent) of 2005 in United States to that in Venezuela?
Your answer should be very brief. 843.15. What is the ratio of the Emissions (1000 metric ton of CO2 equivalent) in 2008 in United States to that in Venezuela?
Your answer should be very brief. 937.71. What is the ratio of the Emissions (1000 metric ton of CO2 equivalent) of 2000 in Uzbekistan to that in Venezuela?
Ensure brevity in your answer.  3.64. What is the ratio of the Emissions (1000 metric ton of CO2 equivalent) of 2005 in Uzbekistan to that in Venezuela?
Ensure brevity in your answer.  3.43. What is the ratio of the Emissions (1000 metric ton of CO2 equivalent) of 2008 in Uzbekistan to that in Venezuela?
Your response must be concise. 4.31. What is the difference between the highest and the second highest Emissions (1000 metric ton of CO2 equivalent) of 1990?
Offer a terse response. 2.20e+04. What is the difference between the highest and the second highest Emissions (1000 metric ton of CO2 equivalent) of 2000?
Keep it short and to the point. 1.87e+04. What is the difference between the highest and the second highest Emissions (1000 metric ton of CO2 equivalent) in 2005?
Provide a short and direct response. 1.56e+04. What is the difference between the highest and the second highest Emissions (1000 metric ton of CO2 equivalent) of 2008?
Provide a succinct answer. 1.41e+04. What is the difference between the highest and the lowest Emissions (1000 metric ton of CO2 equivalent) in 1990?
Make the answer very short. 4.46e+04. What is the difference between the highest and the lowest Emissions (1000 metric ton of CO2 equivalent) of 2000?
Your answer should be very brief. 2.74e+04. What is the difference between the highest and the lowest Emissions (1000 metric ton of CO2 equivalent) in 2005?
Your answer should be very brief. 2.53e+04. What is the difference between the highest and the lowest Emissions (1000 metric ton of CO2 equivalent) of 2008?
Offer a terse response. 2.38e+04. 